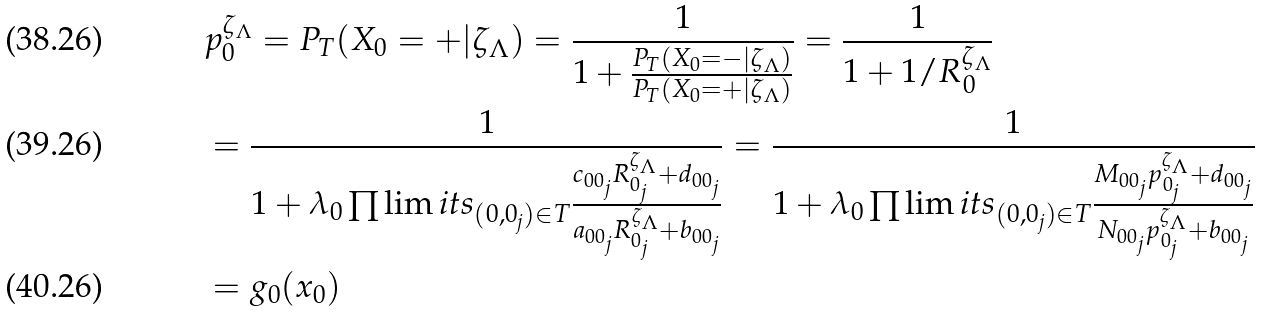Convert formula to latex. <formula><loc_0><loc_0><loc_500><loc_500>& p ^ { \zeta _ { \Lambda } } _ { 0 } = P _ { T } ( X _ { 0 } = + | \zeta _ { \Lambda } ) = \frac { 1 } { 1 + \frac { P _ { T } ( X _ { 0 } = - | \zeta _ { \Lambda } ) } { P _ { T } ( X _ { 0 } = + | \zeta _ { \Lambda } ) } } = \frac { 1 } { 1 + 1 / R ^ { \zeta _ { \Lambda } } _ { 0 } } \\ & = \frac { 1 } { 1 + \lambda _ { 0 } \prod \lim i t s _ { ( 0 , 0 _ { j } ) \in T } \frac { c _ { 0 0 _ { j } } R ^ { \zeta _ { \Lambda } } _ { 0 _ { j } } + d _ { 0 0 _ { j } } } { a _ { 0 0 _ { j } } R ^ { \zeta _ { \Lambda } } _ { 0 _ { j } } + b _ { 0 0 _ { j } } } } = \frac { 1 } { 1 + \lambda _ { 0 } \prod \lim i t s _ { ( 0 , 0 _ { j } ) \in T } \frac { M _ { 0 0 _ { j } } p ^ { \zeta _ { \Lambda } } _ { 0 _ { j } } + d _ { 0 0 _ { j } } } { N _ { 0 0 _ { j } } p ^ { \zeta _ { \Lambda } } _ { 0 _ { j } } + b _ { 0 0 _ { j } } } } \\ & = g _ { 0 } ( x _ { 0 } )</formula> 